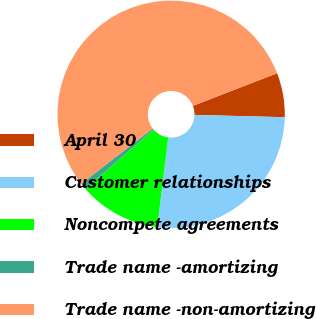<chart> <loc_0><loc_0><loc_500><loc_500><pie_chart><fcel>April 30<fcel>Customer relationships<fcel>Noncompete agreements<fcel>Trade name -amortizing<fcel>Trade name -non-amortizing<nl><fcel>6.29%<fcel>26.55%<fcel>11.66%<fcel>0.92%<fcel>54.58%<nl></chart> 